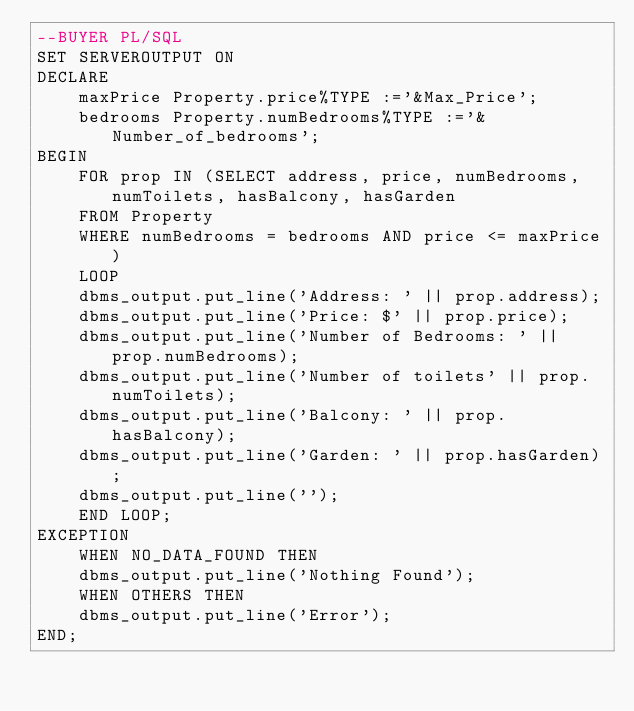Convert code to text. <code><loc_0><loc_0><loc_500><loc_500><_SQL_>--BUYER PL/SQL
SET SERVEROUTPUT ON
DECLARE
    maxPrice Property.price%TYPE :='&Max_Price';
    bedrooms Property.numBedrooms%TYPE :='&Number_of_bedrooms';
BEGIN
    FOR prop IN (SELECT address, price, numBedrooms, numToilets, hasBalcony, hasGarden
    FROM Property
    WHERE numBedrooms = bedrooms AND price <= maxPrice)
    LOOP
    dbms_output.put_line('Address: ' || prop.address); 
    dbms_output.put_line('Price: $' || prop.price);
    dbms_output.put_line('Number of Bedrooms: ' || prop.numBedrooms);
    dbms_output.put_line('Number of toilets' || prop.numToilets);
    dbms_output.put_line('Balcony: ' || prop.hasBalcony);
    dbms_output.put_line('Garden: ' || prop.hasGarden);
    dbms_output.put_line('');
    END LOOP;
EXCEPTION
    WHEN NO_DATA_FOUND THEN
    dbms_output.put_line('Nothing Found');
    WHEN OTHERS THEN
    dbms_output.put_line('Error');
END; 
</code> 